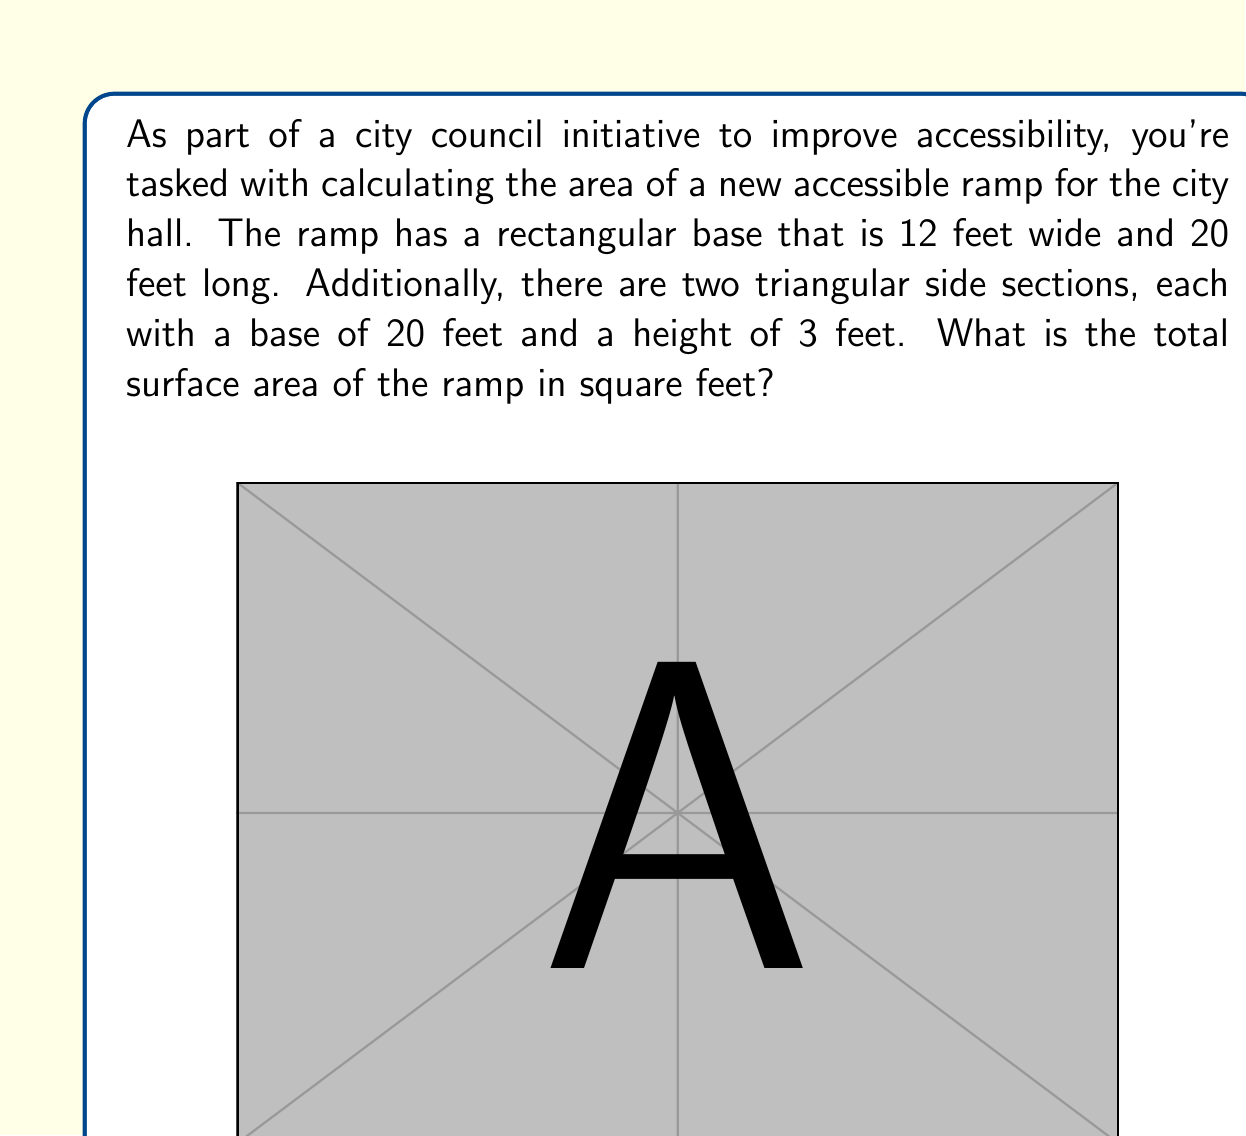Can you answer this question? Let's break this problem down into steps:

1) First, calculate the area of the rectangular base:
   $A_{rectangle} = length \times width$
   $A_{rectangle} = 20 \text{ ft} \times 12 \text{ ft} = 240 \text{ sq ft}$

2) Next, calculate the area of one triangular side section:
   $A_{triangle} = \frac{1}{2} \times base \times height$
   $A_{triangle} = \frac{1}{2} \times 20 \text{ ft} \times 3 \text{ ft} = 30 \text{ sq ft}$

3) Since there are two identical triangular sections, multiply the area of one triangle by 2:
   $A_{two triangles} = 2 \times 30 \text{ sq ft} = 60 \text{ sq ft}$

4) To get the total surface area, add the area of the rectangular base and the two triangular sections:
   $A_{total} = A_{rectangle} + A_{two triangles}$
   $A_{total} = 240 \text{ sq ft} + 60 \text{ sq ft} = 300 \text{ sq ft}$

Therefore, the total surface area of the ramp is 300 square feet.
Answer: 300 sq ft 